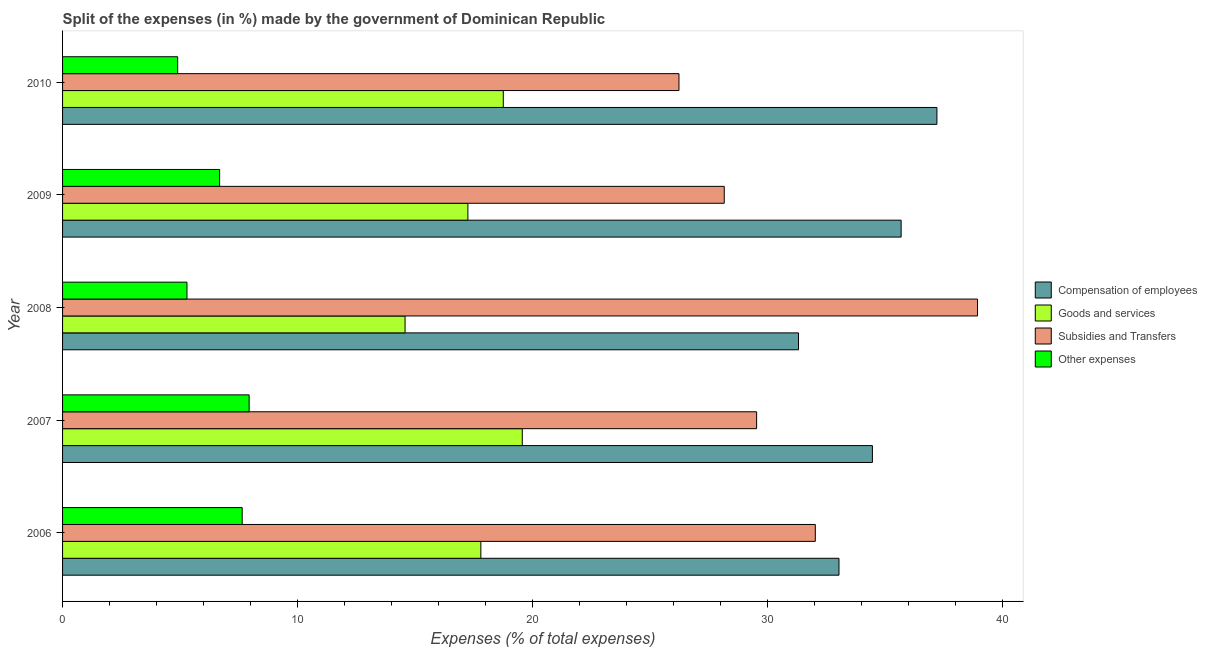How many groups of bars are there?
Offer a very short reply. 5. Are the number of bars per tick equal to the number of legend labels?
Your response must be concise. Yes. Are the number of bars on each tick of the Y-axis equal?
Ensure brevity in your answer.  Yes. What is the label of the 4th group of bars from the top?
Your answer should be compact. 2007. In how many cases, is the number of bars for a given year not equal to the number of legend labels?
Offer a terse response. 0. What is the percentage of amount spent on subsidies in 2006?
Your answer should be very brief. 32.03. Across all years, what is the maximum percentage of amount spent on subsidies?
Make the answer very short. 38.93. Across all years, what is the minimum percentage of amount spent on other expenses?
Keep it short and to the point. 4.9. What is the total percentage of amount spent on other expenses in the graph?
Keep it short and to the point. 32.46. What is the difference between the percentage of amount spent on compensation of employees in 2006 and that in 2007?
Ensure brevity in your answer.  -1.42. What is the difference between the percentage of amount spent on subsidies in 2010 and the percentage of amount spent on other expenses in 2008?
Your answer should be very brief. 20.94. What is the average percentage of amount spent on subsidies per year?
Offer a very short reply. 30.98. In the year 2007, what is the difference between the percentage of amount spent on subsidies and percentage of amount spent on goods and services?
Your answer should be very brief. 9.97. In how many years, is the percentage of amount spent on goods and services greater than 30 %?
Your answer should be compact. 0. What is the ratio of the percentage of amount spent on subsidies in 2008 to that in 2010?
Provide a short and direct response. 1.48. What is the difference between the highest and the second highest percentage of amount spent on subsidies?
Your response must be concise. 6.9. What is the difference between the highest and the lowest percentage of amount spent on other expenses?
Make the answer very short. 3.04. In how many years, is the percentage of amount spent on other expenses greater than the average percentage of amount spent on other expenses taken over all years?
Your answer should be compact. 3. Is it the case that in every year, the sum of the percentage of amount spent on subsidies and percentage of amount spent on other expenses is greater than the sum of percentage of amount spent on compensation of employees and percentage of amount spent on goods and services?
Provide a short and direct response. Yes. What does the 4th bar from the top in 2007 represents?
Provide a short and direct response. Compensation of employees. What does the 1st bar from the bottom in 2008 represents?
Provide a succinct answer. Compensation of employees. Is it the case that in every year, the sum of the percentage of amount spent on compensation of employees and percentage of amount spent on goods and services is greater than the percentage of amount spent on subsidies?
Offer a terse response. Yes. Are the values on the major ticks of X-axis written in scientific E-notation?
Keep it short and to the point. No. Does the graph contain any zero values?
Give a very brief answer. No. Does the graph contain grids?
Your answer should be compact. No. Where does the legend appear in the graph?
Make the answer very short. Center right. How many legend labels are there?
Ensure brevity in your answer.  4. What is the title of the graph?
Provide a succinct answer. Split of the expenses (in %) made by the government of Dominican Republic. Does "Source data assessment" appear as one of the legend labels in the graph?
Give a very brief answer. No. What is the label or title of the X-axis?
Keep it short and to the point. Expenses (% of total expenses). What is the Expenses (% of total expenses) of Compensation of employees in 2006?
Your answer should be compact. 33.04. What is the Expenses (% of total expenses) in Goods and services in 2006?
Offer a terse response. 17.8. What is the Expenses (% of total expenses) in Subsidies and Transfers in 2006?
Provide a succinct answer. 32.03. What is the Expenses (% of total expenses) in Other expenses in 2006?
Keep it short and to the point. 7.64. What is the Expenses (% of total expenses) of Compensation of employees in 2007?
Your answer should be compact. 34.46. What is the Expenses (% of total expenses) in Goods and services in 2007?
Make the answer very short. 19.56. What is the Expenses (% of total expenses) in Subsidies and Transfers in 2007?
Offer a terse response. 29.53. What is the Expenses (% of total expenses) in Other expenses in 2007?
Provide a short and direct response. 7.94. What is the Expenses (% of total expenses) in Compensation of employees in 2008?
Give a very brief answer. 31.32. What is the Expenses (% of total expenses) of Goods and services in 2008?
Offer a very short reply. 14.57. What is the Expenses (% of total expenses) of Subsidies and Transfers in 2008?
Give a very brief answer. 38.93. What is the Expenses (% of total expenses) in Other expenses in 2008?
Offer a very short reply. 5.29. What is the Expenses (% of total expenses) in Compensation of employees in 2009?
Keep it short and to the point. 35.68. What is the Expenses (% of total expenses) in Goods and services in 2009?
Keep it short and to the point. 17.25. What is the Expenses (% of total expenses) in Subsidies and Transfers in 2009?
Your answer should be very brief. 28.16. What is the Expenses (% of total expenses) in Other expenses in 2009?
Provide a short and direct response. 6.68. What is the Expenses (% of total expenses) in Compensation of employees in 2010?
Offer a very short reply. 37.21. What is the Expenses (% of total expenses) in Goods and services in 2010?
Provide a short and direct response. 18.75. What is the Expenses (% of total expenses) in Subsidies and Transfers in 2010?
Your response must be concise. 26.23. What is the Expenses (% of total expenses) of Other expenses in 2010?
Give a very brief answer. 4.9. Across all years, what is the maximum Expenses (% of total expenses) of Compensation of employees?
Offer a very short reply. 37.21. Across all years, what is the maximum Expenses (% of total expenses) in Goods and services?
Keep it short and to the point. 19.56. Across all years, what is the maximum Expenses (% of total expenses) in Subsidies and Transfers?
Make the answer very short. 38.93. Across all years, what is the maximum Expenses (% of total expenses) of Other expenses?
Ensure brevity in your answer.  7.94. Across all years, what is the minimum Expenses (% of total expenses) of Compensation of employees?
Provide a succinct answer. 31.32. Across all years, what is the minimum Expenses (% of total expenses) in Goods and services?
Make the answer very short. 14.57. Across all years, what is the minimum Expenses (% of total expenses) of Subsidies and Transfers?
Ensure brevity in your answer.  26.23. Across all years, what is the minimum Expenses (% of total expenses) in Other expenses?
Offer a very short reply. 4.9. What is the total Expenses (% of total expenses) in Compensation of employees in the graph?
Offer a very short reply. 171.71. What is the total Expenses (% of total expenses) of Goods and services in the graph?
Your answer should be very brief. 87.94. What is the total Expenses (% of total expenses) in Subsidies and Transfers in the graph?
Keep it short and to the point. 154.88. What is the total Expenses (% of total expenses) in Other expenses in the graph?
Your response must be concise. 32.46. What is the difference between the Expenses (% of total expenses) of Compensation of employees in 2006 and that in 2007?
Give a very brief answer. -1.42. What is the difference between the Expenses (% of total expenses) of Goods and services in 2006 and that in 2007?
Provide a short and direct response. -1.76. What is the difference between the Expenses (% of total expenses) in Subsidies and Transfers in 2006 and that in 2007?
Offer a very short reply. 2.5. What is the difference between the Expenses (% of total expenses) in Other expenses in 2006 and that in 2007?
Offer a terse response. -0.3. What is the difference between the Expenses (% of total expenses) of Compensation of employees in 2006 and that in 2008?
Keep it short and to the point. 1.72. What is the difference between the Expenses (% of total expenses) in Goods and services in 2006 and that in 2008?
Give a very brief answer. 3.23. What is the difference between the Expenses (% of total expenses) of Subsidies and Transfers in 2006 and that in 2008?
Your answer should be compact. -6.9. What is the difference between the Expenses (% of total expenses) of Other expenses in 2006 and that in 2008?
Make the answer very short. 2.35. What is the difference between the Expenses (% of total expenses) in Compensation of employees in 2006 and that in 2009?
Your response must be concise. -2.65. What is the difference between the Expenses (% of total expenses) of Goods and services in 2006 and that in 2009?
Make the answer very short. 0.55. What is the difference between the Expenses (% of total expenses) of Subsidies and Transfers in 2006 and that in 2009?
Offer a terse response. 3.88. What is the difference between the Expenses (% of total expenses) in Other expenses in 2006 and that in 2009?
Provide a succinct answer. 0.96. What is the difference between the Expenses (% of total expenses) in Compensation of employees in 2006 and that in 2010?
Make the answer very short. -4.17. What is the difference between the Expenses (% of total expenses) of Goods and services in 2006 and that in 2010?
Your answer should be very brief. -0.96. What is the difference between the Expenses (% of total expenses) of Subsidies and Transfers in 2006 and that in 2010?
Ensure brevity in your answer.  5.8. What is the difference between the Expenses (% of total expenses) of Other expenses in 2006 and that in 2010?
Keep it short and to the point. 2.75. What is the difference between the Expenses (% of total expenses) of Compensation of employees in 2007 and that in 2008?
Keep it short and to the point. 3.14. What is the difference between the Expenses (% of total expenses) in Goods and services in 2007 and that in 2008?
Provide a succinct answer. 4.99. What is the difference between the Expenses (% of total expenses) of Subsidies and Transfers in 2007 and that in 2008?
Provide a short and direct response. -9.4. What is the difference between the Expenses (% of total expenses) of Other expenses in 2007 and that in 2008?
Provide a succinct answer. 2.65. What is the difference between the Expenses (% of total expenses) of Compensation of employees in 2007 and that in 2009?
Your response must be concise. -1.22. What is the difference between the Expenses (% of total expenses) of Goods and services in 2007 and that in 2009?
Your answer should be compact. 2.31. What is the difference between the Expenses (% of total expenses) of Subsidies and Transfers in 2007 and that in 2009?
Your response must be concise. 1.38. What is the difference between the Expenses (% of total expenses) of Other expenses in 2007 and that in 2009?
Offer a terse response. 1.26. What is the difference between the Expenses (% of total expenses) in Compensation of employees in 2007 and that in 2010?
Offer a very short reply. -2.75. What is the difference between the Expenses (% of total expenses) of Goods and services in 2007 and that in 2010?
Provide a short and direct response. 0.81. What is the difference between the Expenses (% of total expenses) in Subsidies and Transfers in 2007 and that in 2010?
Provide a short and direct response. 3.3. What is the difference between the Expenses (% of total expenses) in Other expenses in 2007 and that in 2010?
Give a very brief answer. 3.04. What is the difference between the Expenses (% of total expenses) in Compensation of employees in 2008 and that in 2009?
Your response must be concise. -4.37. What is the difference between the Expenses (% of total expenses) of Goods and services in 2008 and that in 2009?
Give a very brief answer. -2.67. What is the difference between the Expenses (% of total expenses) in Subsidies and Transfers in 2008 and that in 2009?
Your response must be concise. 10.78. What is the difference between the Expenses (% of total expenses) of Other expenses in 2008 and that in 2009?
Offer a very short reply. -1.39. What is the difference between the Expenses (% of total expenses) of Compensation of employees in 2008 and that in 2010?
Give a very brief answer. -5.89. What is the difference between the Expenses (% of total expenses) in Goods and services in 2008 and that in 2010?
Provide a short and direct response. -4.18. What is the difference between the Expenses (% of total expenses) in Subsidies and Transfers in 2008 and that in 2010?
Your answer should be compact. 12.7. What is the difference between the Expenses (% of total expenses) in Other expenses in 2008 and that in 2010?
Your answer should be very brief. 0.4. What is the difference between the Expenses (% of total expenses) in Compensation of employees in 2009 and that in 2010?
Your answer should be compact. -1.52. What is the difference between the Expenses (% of total expenses) in Goods and services in 2009 and that in 2010?
Ensure brevity in your answer.  -1.51. What is the difference between the Expenses (% of total expenses) in Subsidies and Transfers in 2009 and that in 2010?
Keep it short and to the point. 1.93. What is the difference between the Expenses (% of total expenses) in Other expenses in 2009 and that in 2010?
Provide a short and direct response. 1.78. What is the difference between the Expenses (% of total expenses) of Compensation of employees in 2006 and the Expenses (% of total expenses) of Goods and services in 2007?
Make the answer very short. 13.48. What is the difference between the Expenses (% of total expenses) in Compensation of employees in 2006 and the Expenses (% of total expenses) in Subsidies and Transfers in 2007?
Your response must be concise. 3.5. What is the difference between the Expenses (% of total expenses) in Compensation of employees in 2006 and the Expenses (% of total expenses) in Other expenses in 2007?
Your answer should be compact. 25.1. What is the difference between the Expenses (% of total expenses) in Goods and services in 2006 and the Expenses (% of total expenses) in Subsidies and Transfers in 2007?
Offer a very short reply. -11.73. What is the difference between the Expenses (% of total expenses) in Goods and services in 2006 and the Expenses (% of total expenses) in Other expenses in 2007?
Make the answer very short. 9.86. What is the difference between the Expenses (% of total expenses) in Subsidies and Transfers in 2006 and the Expenses (% of total expenses) in Other expenses in 2007?
Your answer should be compact. 24.09. What is the difference between the Expenses (% of total expenses) of Compensation of employees in 2006 and the Expenses (% of total expenses) of Goods and services in 2008?
Make the answer very short. 18.46. What is the difference between the Expenses (% of total expenses) of Compensation of employees in 2006 and the Expenses (% of total expenses) of Subsidies and Transfers in 2008?
Offer a very short reply. -5.89. What is the difference between the Expenses (% of total expenses) in Compensation of employees in 2006 and the Expenses (% of total expenses) in Other expenses in 2008?
Offer a very short reply. 27.74. What is the difference between the Expenses (% of total expenses) in Goods and services in 2006 and the Expenses (% of total expenses) in Subsidies and Transfers in 2008?
Provide a short and direct response. -21.13. What is the difference between the Expenses (% of total expenses) in Goods and services in 2006 and the Expenses (% of total expenses) in Other expenses in 2008?
Your answer should be very brief. 12.51. What is the difference between the Expenses (% of total expenses) of Subsidies and Transfers in 2006 and the Expenses (% of total expenses) of Other expenses in 2008?
Make the answer very short. 26.74. What is the difference between the Expenses (% of total expenses) in Compensation of employees in 2006 and the Expenses (% of total expenses) in Goods and services in 2009?
Provide a succinct answer. 15.79. What is the difference between the Expenses (% of total expenses) in Compensation of employees in 2006 and the Expenses (% of total expenses) in Subsidies and Transfers in 2009?
Provide a short and direct response. 4.88. What is the difference between the Expenses (% of total expenses) of Compensation of employees in 2006 and the Expenses (% of total expenses) of Other expenses in 2009?
Your response must be concise. 26.36. What is the difference between the Expenses (% of total expenses) in Goods and services in 2006 and the Expenses (% of total expenses) in Subsidies and Transfers in 2009?
Make the answer very short. -10.36. What is the difference between the Expenses (% of total expenses) in Goods and services in 2006 and the Expenses (% of total expenses) in Other expenses in 2009?
Offer a terse response. 11.12. What is the difference between the Expenses (% of total expenses) of Subsidies and Transfers in 2006 and the Expenses (% of total expenses) of Other expenses in 2009?
Provide a succinct answer. 25.35. What is the difference between the Expenses (% of total expenses) in Compensation of employees in 2006 and the Expenses (% of total expenses) in Goods and services in 2010?
Keep it short and to the point. 14.28. What is the difference between the Expenses (% of total expenses) of Compensation of employees in 2006 and the Expenses (% of total expenses) of Subsidies and Transfers in 2010?
Make the answer very short. 6.81. What is the difference between the Expenses (% of total expenses) in Compensation of employees in 2006 and the Expenses (% of total expenses) in Other expenses in 2010?
Provide a short and direct response. 28.14. What is the difference between the Expenses (% of total expenses) of Goods and services in 2006 and the Expenses (% of total expenses) of Subsidies and Transfers in 2010?
Offer a terse response. -8.43. What is the difference between the Expenses (% of total expenses) in Goods and services in 2006 and the Expenses (% of total expenses) in Other expenses in 2010?
Provide a short and direct response. 12.9. What is the difference between the Expenses (% of total expenses) in Subsidies and Transfers in 2006 and the Expenses (% of total expenses) in Other expenses in 2010?
Your response must be concise. 27.13. What is the difference between the Expenses (% of total expenses) in Compensation of employees in 2007 and the Expenses (% of total expenses) in Goods and services in 2008?
Provide a short and direct response. 19.89. What is the difference between the Expenses (% of total expenses) in Compensation of employees in 2007 and the Expenses (% of total expenses) in Subsidies and Transfers in 2008?
Offer a very short reply. -4.47. What is the difference between the Expenses (% of total expenses) in Compensation of employees in 2007 and the Expenses (% of total expenses) in Other expenses in 2008?
Keep it short and to the point. 29.17. What is the difference between the Expenses (% of total expenses) in Goods and services in 2007 and the Expenses (% of total expenses) in Subsidies and Transfers in 2008?
Offer a terse response. -19.37. What is the difference between the Expenses (% of total expenses) of Goods and services in 2007 and the Expenses (% of total expenses) of Other expenses in 2008?
Offer a terse response. 14.27. What is the difference between the Expenses (% of total expenses) of Subsidies and Transfers in 2007 and the Expenses (% of total expenses) of Other expenses in 2008?
Keep it short and to the point. 24.24. What is the difference between the Expenses (% of total expenses) of Compensation of employees in 2007 and the Expenses (% of total expenses) of Goods and services in 2009?
Your answer should be very brief. 17.21. What is the difference between the Expenses (% of total expenses) of Compensation of employees in 2007 and the Expenses (% of total expenses) of Subsidies and Transfers in 2009?
Ensure brevity in your answer.  6.3. What is the difference between the Expenses (% of total expenses) of Compensation of employees in 2007 and the Expenses (% of total expenses) of Other expenses in 2009?
Ensure brevity in your answer.  27.78. What is the difference between the Expenses (% of total expenses) in Goods and services in 2007 and the Expenses (% of total expenses) in Subsidies and Transfers in 2009?
Make the answer very short. -8.59. What is the difference between the Expenses (% of total expenses) in Goods and services in 2007 and the Expenses (% of total expenses) in Other expenses in 2009?
Your response must be concise. 12.88. What is the difference between the Expenses (% of total expenses) of Subsidies and Transfers in 2007 and the Expenses (% of total expenses) of Other expenses in 2009?
Your response must be concise. 22.85. What is the difference between the Expenses (% of total expenses) in Compensation of employees in 2007 and the Expenses (% of total expenses) in Goods and services in 2010?
Your response must be concise. 15.71. What is the difference between the Expenses (% of total expenses) of Compensation of employees in 2007 and the Expenses (% of total expenses) of Subsidies and Transfers in 2010?
Your response must be concise. 8.23. What is the difference between the Expenses (% of total expenses) of Compensation of employees in 2007 and the Expenses (% of total expenses) of Other expenses in 2010?
Your answer should be very brief. 29.56. What is the difference between the Expenses (% of total expenses) in Goods and services in 2007 and the Expenses (% of total expenses) in Subsidies and Transfers in 2010?
Keep it short and to the point. -6.67. What is the difference between the Expenses (% of total expenses) of Goods and services in 2007 and the Expenses (% of total expenses) of Other expenses in 2010?
Keep it short and to the point. 14.66. What is the difference between the Expenses (% of total expenses) in Subsidies and Transfers in 2007 and the Expenses (% of total expenses) in Other expenses in 2010?
Provide a succinct answer. 24.64. What is the difference between the Expenses (% of total expenses) in Compensation of employees in 2008 and the Expenses (% of total expenses) in Goods and services in 2009?
Your answer should be compact. 14.07. What is the difference between the Expenses (% of total expenses) of Compensation of employees in 2008 and the Expenses (% of total expenses) of Subsidies and Transfers in 2009?
Offer a terse response. 3.16. What is the difference between the Expenses (% of total expenses) in Compensation of employees in 2008 and the Expenses (% of total expenses) in Other expenses in 2009?
Make the answer very short. 24.63. What is the difference between the Expenses (% of total expenses) in Goods and services in 2008 and the Expenses (% of total expenses) in Subsidies and Transfers in 2009?
Your answer should be very brief. -13.58. What is the difference between the Expenses (% of total expenses) in Goods and services in 2008 and the Expenses (% of total expenses) in Other expenses in 2009?
Make the answer very short. 7.89. What is the difference between the Expenses (% of total expenses) of Subsidies and Transfers in 2008 and the Expenses (% of total expenses) of Other expenses in 2009?
Provide a short and direct response. 32.25. What is the difference between the Expenses (% of total expenses) in Compensation of employees in 2008 and the Expenses (% of total expenses) in Goods and services in 2010?
Keep it short and to the point. 12.56. What is the difference between the Expenses (% of total expenses) of Compensation of employees in 2008 and the Expenses (% of total expenses) of Subsidies and Transfers in 2010?
Keep it short and to the point. 5.09. What is the difference between the Expenses (% of total expenses) of Compensation of employees in 2008 and the Expenses (% of total expenses) of Other expenses in 2010?
Your answer should be compact. 26.42. What is the difference between the Expenses (% of total expenses) of Goods and services in 2008 and the Expenses (% of total expenses) of Subsidies and Transfers in 2010?
Provide a short and direct response. -11.66. What is the difference between the Expenses (% of total expenses) of Goods and services in 2008 and the Expenses (% of total expenses) of Other expenses in 2010?
Provide a short and direct response. 9.68. What is the difference between the Expenses (% of total expenses) of Subsidies and Transfers in 2008 and the Expenses (% of total expenses) of Other expenses in 2010?
Keep it short and to the point. 34.04. What is the difference between the Expenses (% of total expenses) of Compensation of employees in 2009 and the Expenses (% of total expenses) of Goods and services in 2010?
Make the answer very short. 16.93. What is the difference between the Expenses (% of total expenses) in Compensation of employees in 2009 and the Expenses (% of total expenses) in Subsidies and Transfers in 2010?
Keep it short and to the point. 9.45. What is the difference between the Expenses (% of total expenses) in Compensation of employees in 2009 and the Expenses (% of total expenses) in Other expenses in 2010?
Your answer should be very brief. 30.79. What is the difference between the Expenses (% of total expenses) of Goods and services in 2009 and the Expenses (% of total expenses) of Subsidies and Transfers in 2010?
Give a very brief answer. -8.98. What is the difference between the Expenses (% of total expenses) of Goods and services in 2009 and the Expenses (% of total expenses) of Other expenses in 2010?
Your response must be concise. 12.35. What is the difference between the Expenses (% of total expenses) of Subsidies and Transfers in 2009 and the Expenses (% of total expenses) of Other expenses in 2010?
Ensure brevity in your answer.  23.26. What is the average Expenses (% of total expenses) of Compensation of employees per year?
Keep it short and to the point. 34.34. What is the average Expenses (% of total expenses) in Goods and services per year?
Offer a terse response. 17.59. What is the average Expenses (% of total expenses) of Subsidies and Transfers per year?
Provide a short and direct response. 30.98. What is the average Expenses (% of total expenses) of Other expenses per year?
Keep it short and to the point. 6.49. In the year 2006, what is the difference between the Expenses (% of total expenses) of Compensation of employees and Expenses (% of total expenses) of Goods and services?
Give a very brief answer. 15.24. In the year 2006, what is the difference between the Expenses (% of total expenses) in Compensation of employees and Expenses (% of total expenses) in Subsidies and Transfers?
Provide a short and direct response. 1.01. In the year 2006, what is the difference between the Expenses (% of total expenses) of Compensation of employees and Expenses (% of total expenses) of Other expenses?
Keep it short and to the point. 25.4. In the year 2006, what is the difference between the Expenses (% of total expenses) in Goods and services and Expenses (% of total expenses) in Subsidies and Transfers?
Provide a short and direct response. -14.23. In the year 2006, what is the difference between the Expenses (% of total expenses) in Goods and services and Expenses (% of total expenses) in Other expenses?
Your answer should be very brief. 10.16. In the year 2006, what is the difference between the Expenses (% of total expenses) in Subsidies and Transfers and Expenses (% of total expenses) in Other expenses?
Provide a succinct answer. 24.39. In the year 2007, what is the difference between the Expenses (% of total expenses) of Compensation of employees and Expenses (% of total expenses) of Goods and services?
Offer a very short reply. 14.9. In the year 2007, what is the difference between the Expenses (% of total expenses) of Compensation of employees and Expenses (% of total expenses) of Subsidies and Transfers?
Your response must be concise. 4.93. In the year 2007, what is the difference between the Expenses (% of total expenses) in Compensation of employees and Expenses (% of total expenses) in Other expenses?
Offer a terse response. 26.52. In the year 2007, what is the difference between the Expenses (% of total expenses) in Goods and services and Expenses (% of total expenses) in Subsidies and Transfers?
Your answer should be compact. -9.97. In the year 2007, what is the difference between the Expenses (% of total expenses) of Goods and services and Expenses (% of total expenses) of Other expenses?
Offer a very short reply. 11.62. In the year 2007, what is the difference between the Expenses (% of total expenses) of Subsidies and Transfers and Expenses (% of total expenses) of Other expenses?
Provide a succinct answer. 21.59. In the year 2008, what is the difference between the Expenses (% of total expenses) in Compensation of employees and Expenses (% of total expenses) in Goods and services?
Ensure brevity in your answer.  16.74. In the year 2008, what is the difference between the Expenses (% of total expenses) of Compensation of employees and Expenses (% of total expenses) of Subsidies and Transfers?
Offer a terse response. -7.62. In the year 2008, what is the difference between the Expenses (% of total expenses) in Compensation of employees and Expenses (% of total expenses) in Other expenses?
Your response must be concise. 26.02. In the year 2008, what is the difference between the Expenses (% of total expenses) in Goods and services and Expenses (% of total expenses) in Subsidies and Transfers?
Offer a very short reply. -24.36. In the year 2008, what is the difference between the Expenses (% of total expenses) of Goods and services and Expenses (% of total expenses) of Other expenses?
Offer a very short reply. 9.28. In the year 2008, what is the difference between the Expenses (% of total expenses) of Subsidies and Transfers and Expenses (% of total expenses) of Other expenses?
Make the answer very short. 33.64. In the year 2009, what is the difference between the Expenses (% of total expenses) in Compensation of employees and Expenses (% of total expenses) in Goods and services?
Ensure brevity in your answer.  18.44. In the year 2009, what is the difference between the Expenses (% of total expenses) in Compensation of employees and Expenses (% of total expenses) in Subsidies and Transfers?
Make the answer very short. 7.53. In the year 2009, what is the difference between the Expenses (% of total expenses) of Compensation of employees and Expenses (% of total expenses) of Other expenses?
Give a very brief answer. 29. In the year 2009, what is the difference between the Expenses (% of total expenses) in Goods and services and Expenses (% of total expenses) in Subsidies and Transfers?
Ensure brevity in your answer.  -10.91. In the year 2009, what is the difference between the Expenses (% of total expenses) of Goods and services and Expenses (% of total expenses) of Other expenses?
Make the answer very short. 10.56. In the year 2009, what is the difference between the Expenses (% of total expenses) in Subsidies and Transfers and Expenses (% of total expenses) in Other expenses?
Keep it short and to the point. 21.47. In the year 2010, what is the difference between the Expenses (% of total expenses) of Compensation of employees and Expenses (% of total expenses) of Goods and services?
Offer a very short reply. 18.45. In the year 2010, what is the difference between the Expenses (% of total expenses) of Compensation of employees and Expenses (% of total expenses) of Subsidies and Transfers?
Provide a succinct answer. 10.98. In the year 2010, what is the difference between the Expenses (% of total expenses) in Compensation of employees and Expenses (% of total expenses) in Other expenses?
Offer a terse response. 32.31. In the year 2010, what is the difference between the Expenses (% of total expenses) of Goods and services and Expenses (% of total expenses) of Subsidies and Transfers?
Offer a terse response. -7.48. In the year 2010, what is the difference between the Expenses (% of total expenses) in Goods and services and Expenses (% of total expenses) in Other expenses?
Provide a short and direct response. 13.86. In the year 2010, what is the difference between the Expenses (% of total expenses) in Subsidies and Transfers and Expenses (% of total expenses) in Other expenses?
Offer a very short reply. 21.33. What is the ratio of the Expenses (% of total expenses) of Compensation of employees in 2006 to that in 2007?
Ensure brevity in your answer.  0.96. What is the ratio of the Expenses (% of total expenses) of Goods and services in 2006 to that in 2007?
Keep it short and to the point. 0.91. What is the ratio of the Expenses (% of total expenses) of Subsidies and Transfers in 2006 to that in 2007?
Keep it short and to the point. 1.08. What is the ratio of the Expenses (% of total expenses) of Other expenses in 2006 to that in 2007?
Keep it short and to the point. 0.96. What is the ratio of the Expenses (% of total expenses) in Compensation of employees in 2006 to that in 2008?
Offer a very short reply. 1.05. What is the ratio of the Expenses (% of total expenses) of Goods and services in 2006 to that in 2008?
Your answer should be compact. 1.22. What is the ratio of the Expenses (% of total expenses) in Subsidies and Transfers in 2006 to that in 2008?
Make the answer very short. 0.82. What is the ratio of the Expenses (% of total expenses) of Other expenses in 2006 to that in 2008?
Your answer should be very brief. 1.44. What is the ratio of the Expenses (% of total expenses) in Compensation of employees in 2006 to that in 2009?
Your answer should be very brief. 0.93. What is the ratio of the Expenses (% of total expenses) in Goods and services in 2006 to that in 2009?
Provide a short and direct response. 1.03. What is the ratio of the Expenses (% of total expenses) of Subsidies and Transfers in 2006 to that in 2009?
Provide a succinct answer. 1.14. What is the ratio of the Expenses (% of total expenses) of Other expenses in 2006 to that in 2009?
Provide a succinct answer. 1.14. What is the ratio of the Expenses (% of total expenses) in Compensation of employees in 2006 to that in 2010?
Your answer should be very brief. 0.89. What is the ratio of the Expenses (% of total expenses) of Goods and services in 2006 to that in 2010?
Offer a terse response. 0.95. What is the ratio of the Expenses (% of total expenses) in Subsidies and Transfers in 2006 to that in 2010?
Your response must be concise. 1.22. What is the ratio of the Expenses (% of total expenses) of Other expenses in 2006 to that in 2010?
Your answer should be very brief. 1.56. What is the ratio of the Expenses (% of total expenses) of Compensation of employees in 2007 to that in 2008?
Keep it short and to the point. 1.1. What is the ratio of the Expenses (% of total expenses) in Goods and services in 2007 to that in 2008?
Keep it short and to the point. 1.34. What is the ratio of the Expenses (% of total expenses) in Subsidies and Transfers in 2007 to that in 2008?
Offer a terse response. 0.76. What is the ratio of the Expenses (% of total expenses) in Other expenses in 2007 to that in 2008?
Provide a short and direct response. 1.5. What is the ratio of the Expenses (% of total expenses) of Compensation of employees in 2007 to that in 2009?
Your response must be concise. 0.97. What is the ratio of the Expenses (% of total expenses) in Goods and services in 2007 to that in 2009?
Your answer should be compact. 1.13. What is the ratio of the Expenses (% of total expenses) in Subsidies and Transfers in 2007 to that in 2009?
Offer a very short reply. 1.05. What is the ratio of the Expenses (% of total expenses) of Other expenses in 2007 to that in 2009?
Offer a very short reply. 1.19. What is the ratio of the Expenses (% of total expenses) of Compensation of employees in 2007 to that in 2010?
Your response must be concise. 0.93. What is the ratio of the Expenses (% of total expenses) in Goods and services in 2007 to that in 2010?
Your answer should be very brief. 1.04. What is the ratio of the Expenses (% of total expenses) of Subsidies and Transfers in 2007 to that in 2010?
Offer a very short reply. 1.13. What is the ratio of the Expenses (% of total expenses) of Other expenses in 2007 to that in 2010?
Provide a succinct answer. 1.62. What is the ratio of the Expenses (% of total expenses) of Compensation of employees in 2008 to that in 2009?
Give a very brief answer. 0.88. What is the ratio of the Expenses (% of total expenses) in Goods and services in 2008 to that in 2009?
Your answer should be compact. 0.84. What is the ratio of the Expenses (% of total expenses) of Subsidies and Transfers in 2008 to that in 2009?
Ensure brevity in your answer.  1.38. What is the ratio of the Expenses (% of total expenses) of Other expenses in 2008 to that in 2009?
Provide a succinct answer. 0.79. What is the ratio of the Expenses (% of total expenses) of Compensation of employees in 2008 to that in 2010?
Your answer should be very brief. 0.84. What is the ratio of the Expenses (% of total expenses) in Goods and services in 2008 to that in 2010?
Your response must be concise. 0.78. What is the ratio of the Expenses (% of total expenses) of Subsidies and Transfers in 2008 to that in 2010?
Your response must be concise. 1.48. What is the ratio of the Expenses (% of total expenses) in Other expenses in 2008 to that in 2010?
Provide a succinct answer. 1.08. What is the ratio of the Expenses (% of total expenses) of Compensation of employees in 2009 to that in 2010?
Provide a short and direct response. 0.96. What is the ratio of the Expenses (% of total expenses) of Goods and services in 2009 to that in 2010?
Provide a succinct answer. 0.92. What is the ratio of the Expenses (% of total expenses) in Subsidies and Transfers in 2009 to that in 2010?
Provide a short and direct response. 1.07. What is the ratio of the Expenses (% of total expenses) in Other expenses in 2009 to that in 2010?
Ensure brevity in your answer.  1.36. What is the difference between the highest and the second highest Expenses (% of total expenses) in Compensation of employees?
Give a very brief answer. 1.52. What is the difference between the highest and the second highest Expenses (% of total expenses) in Goods and services?
Provide a succinct answer. 0.81. What is the difference between the highest and the second highest Expenses (% of total expenses) in Subsidies and Transfers?
Provide a succinct answer. 6.9. What is the difference between the highest and the second highest Expenses (% of total expenses) of Other expenses?
Your response must be concise. 0.3. What is the difference between the highest and the lowest Expenses (% of total expenses) of Compensation of employees?
Your answer should be compact. 5.89. What is the difference between the highest and the lowest Expenses (% of total expenses) in Goods and services?
Your answer should be very brief. 4.99. What is the difference between the highest and the lowest Expenses (% of total expenses) of Subsidies and Transfers?
Provide a succinct answer. 12.7. What is the difference between the highest and the lowest Expenses (% of total expenses) of Other expenses?
Offer a very short reply. 3.04. 